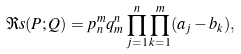<formula> <loc_0><loc_0><loc_500><loc_500>\Re s { ( P ; Q ) } = p _ { n } ^ { m } q _ { m } ^ { n } \prod _ { j = 1 } ^ { n } \prod _ { k = 1 } ^ { m } ( a _ { j } - b _ { k } ) ,</formula> 